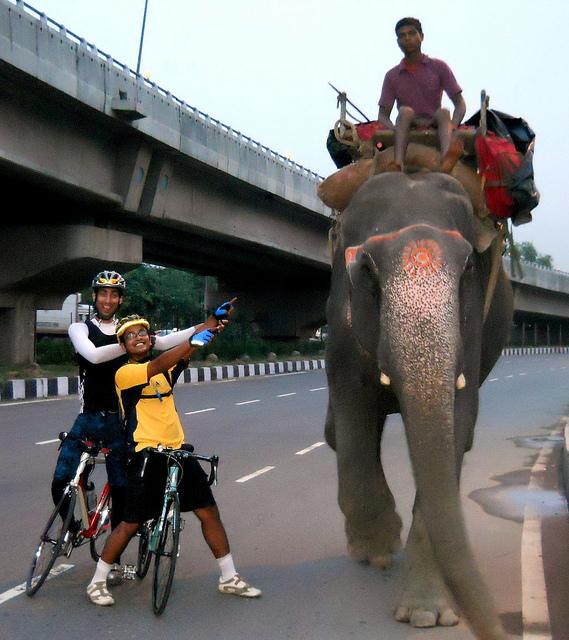Is the Elephant an oddity to the cyclists?
Short answer required. Yes. Do the boys look surprised to see an elephant?
Quick response, please. Yes. What is on the elephant's trunk?
Give a very brief answer. Paint. 